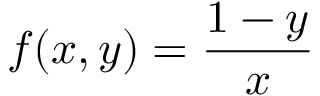Convert formula to latex. <formula><loc_0><loc_0><loc_500><loc_500>f ( x , y ) = { \frac { 1 - y } { x } }</formula> 